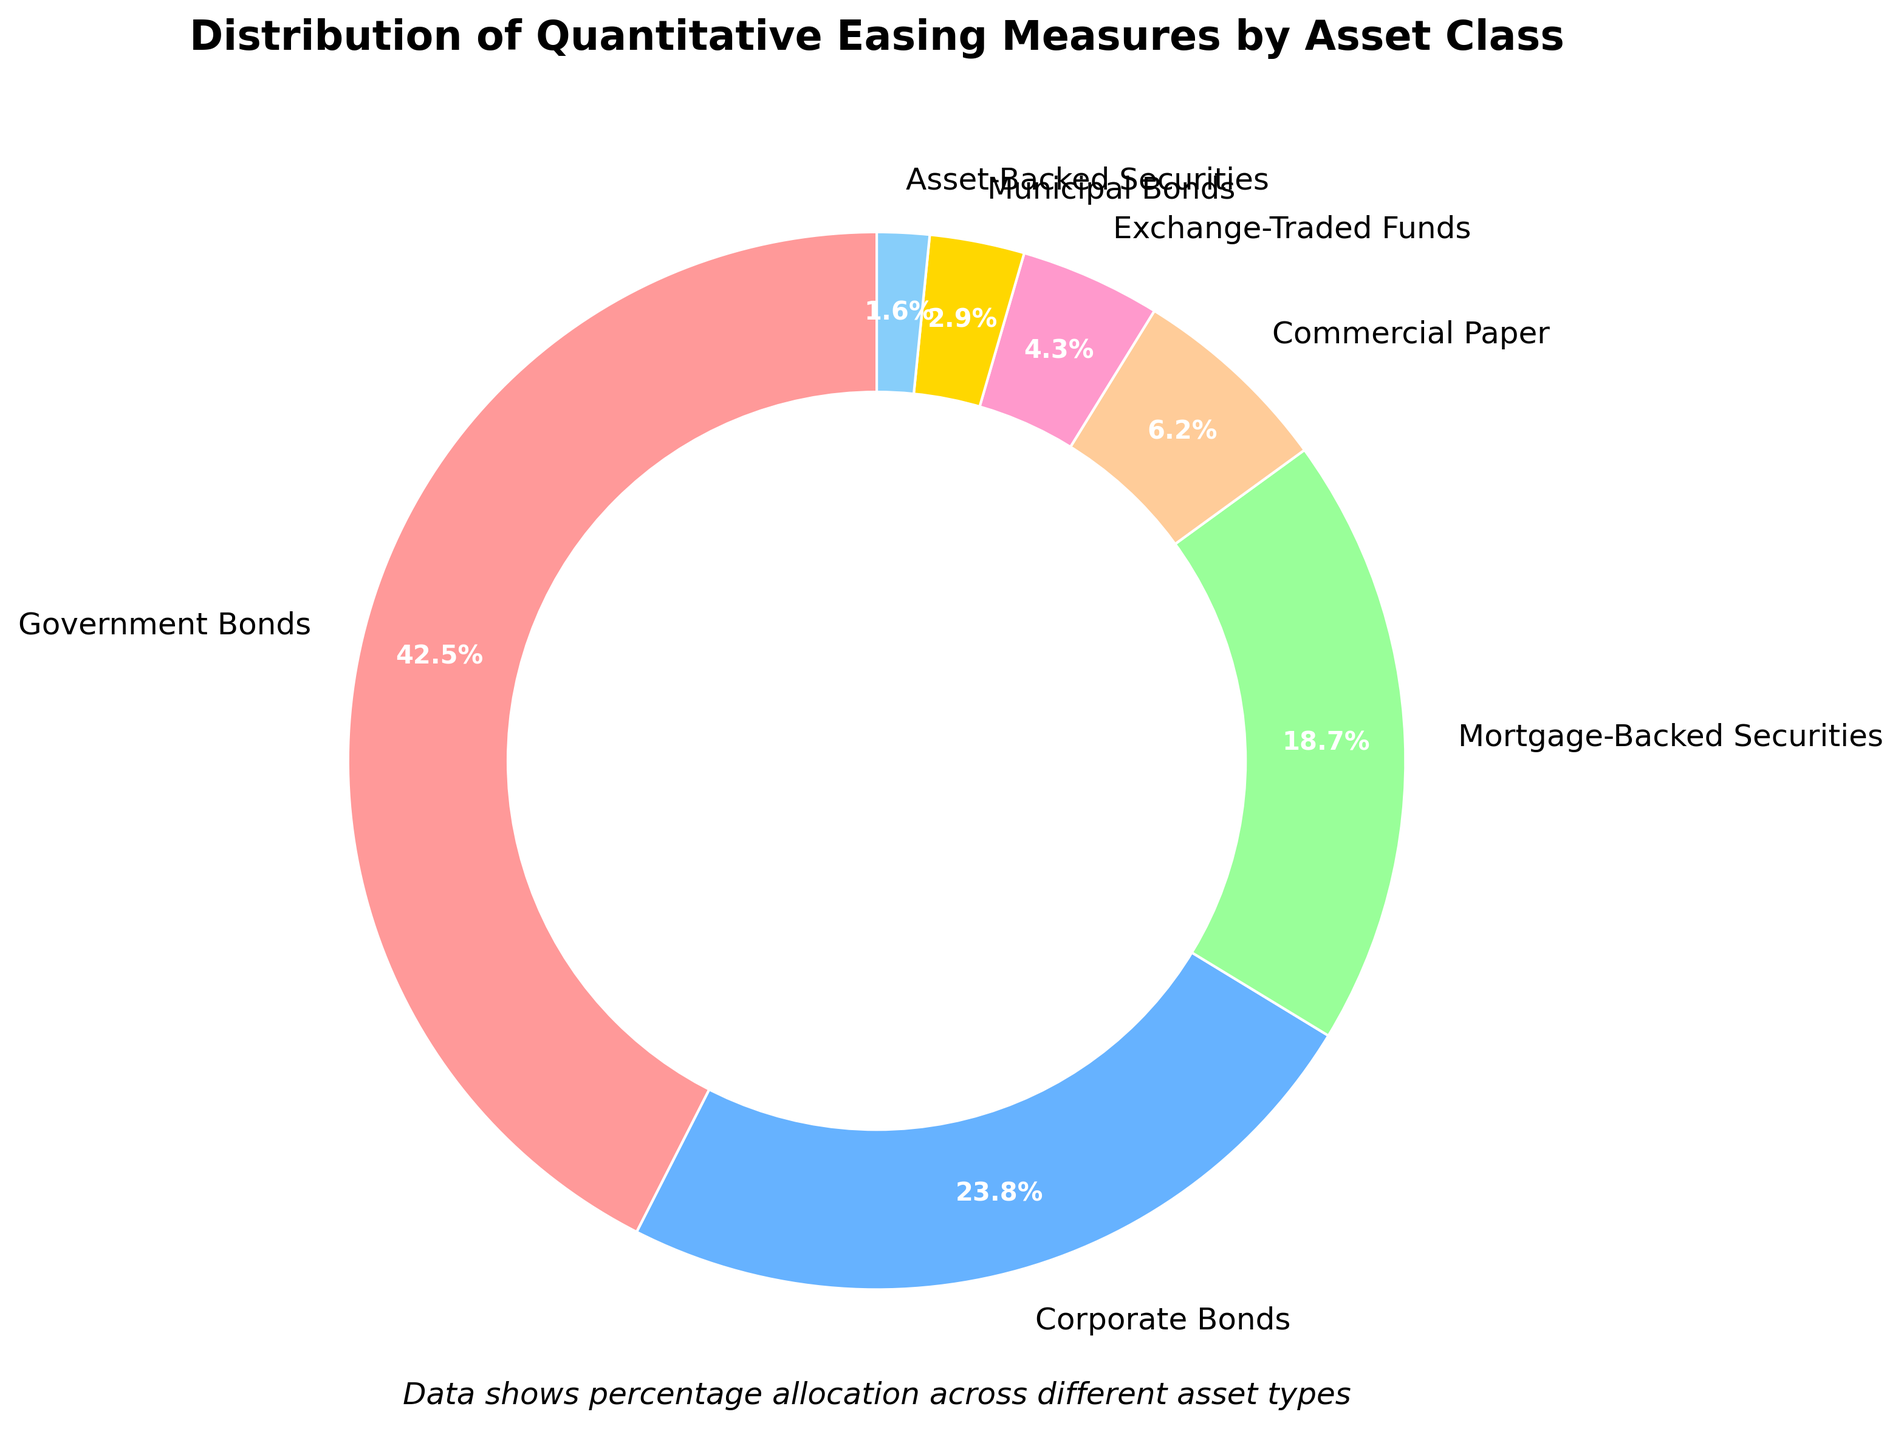What percentage of quantitative easing measures are allocated to government bonds? Look at the segment labeled "Government Bonds" in the pie chart. It shows the percentage directly. In this case, the segment for Government Bonds displays 42.5%
Answer: 42.5% How do corporate bonds compare to mortgage-backed securities in terms of their percentage allocation? Look at the segments labeled "Corporate Bonds" and "Mortgage-Backed Securities". Corporate Bonds occupy 23.8% of the pie chart, and Mortgage-Backed Securities occupy 18.7%. Corporate Bonds thus have a higher allocation.
Answer: Corporate Bonds are higher What is the combined percentage of government bonds and municipal bonds? Add the percentages of Government Bonds (42.5%) and Municipal Bonds (2.9%) from the pie chart. 42.5% + 2.9%= 45.4%
Answer: 45.4% Which asset class has the smallest allocation, and what is its percentage? Look for the smallest slice in the pie chart. The slice labeled "Asset-Backed Securities" is the smallest, with 1.6%.
Answer: Asset-Backed Securities, 1.6% What is the difference in allocation between commercial paper and exchange-traded funds? Check the segments labeled "Commercial Paper" and "Exchange-Traded Funds" in the pie chart. Commercial Paper has an allocation of 6.2%, and Exchange-Traded Funds have 4.3%. Subtract 4.3% from 6.2% results in 1.9%.
Answer: 1.9% Are there more quantitative easing measures allocated to corporate bonds or mortgage-backed securities and asset-backed securities combined? First, find the allocation for Corporate Bonds (23.8%), Mortgage-Backed Securities (18.7%), and Asset-Backed Securities (1.6%). Add 18.7% and 1.6% to get 20.3%. Compare 23.8% to 20.3%; Corporate Bonds have a higher allocation.
Answer: Corporate Bonds How much higher is the allocation for government bonds compared to commercial paper? Look at the segments labeled "Government Bonds" and "Commercial Paper". Government Bonds have 42.5%, while Commercial Paper has 6.2%. Subtract 6.2% from 42.5% to find the difference. 42.5% - 6.2% = 36.3%
Answer: 36.3% Which asset class has just under 20% allocation and is represented by a greenish color? Find the segment with an allocation just under 20% and represented by a greenish color. The "Mortgage-Backed Securities" segment is labeled with 18.7% and has a greenish shade.
Answer: Mortgage-Backed Securities 